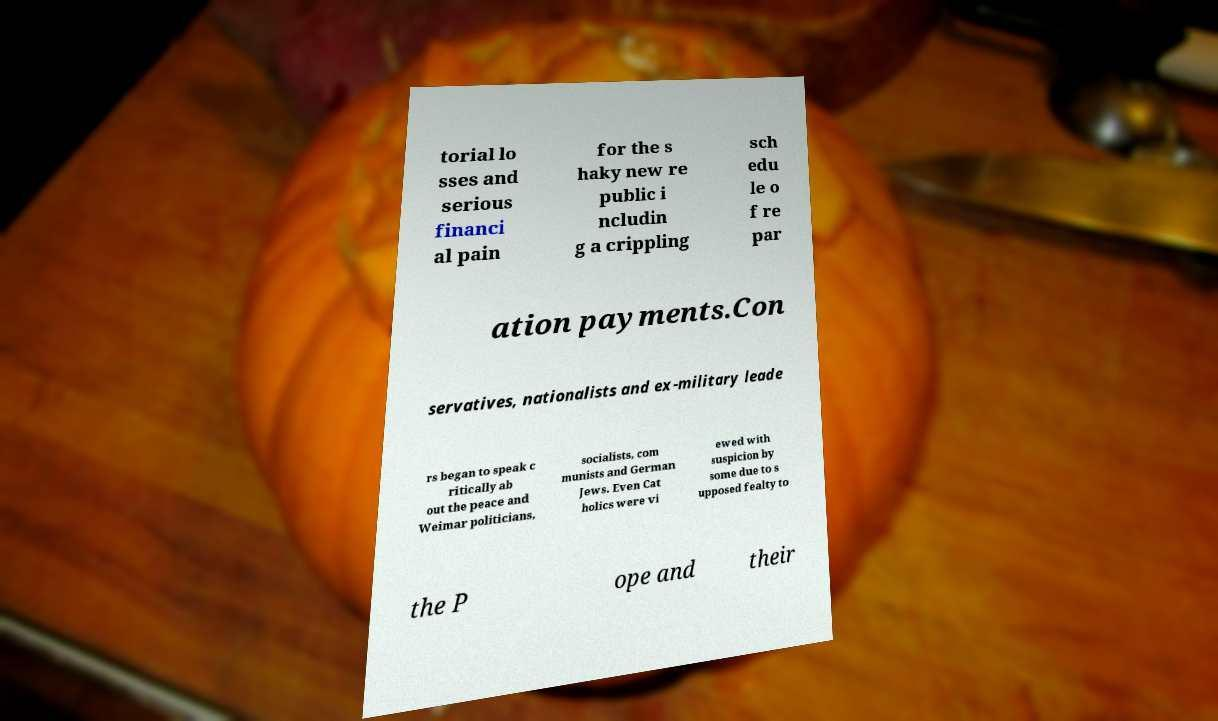Can you accurately transcribe the text from the provided image for me? torial lo sses and serious financi al pain for the s haky new re public i ncludin g a crippling sch edu le o f re par ation payments.Con servatives, nationalists and ex-military leade rs began to speak c ritically ab out the peace and Weimar politicians, socialists, com munists and German Jews. Even Cat holics were vi ewed with suspicion by some due to s upposed fealty to the P ope and their 